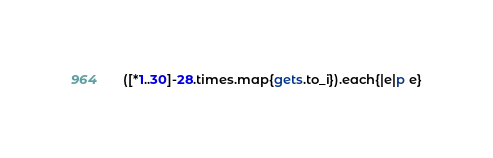<code> <loc_0><loc_0><loc_500><loc_500><_Ruby_>([*1..30]-28.times.map{gets.to_i}).each{|e|p e}</code> 